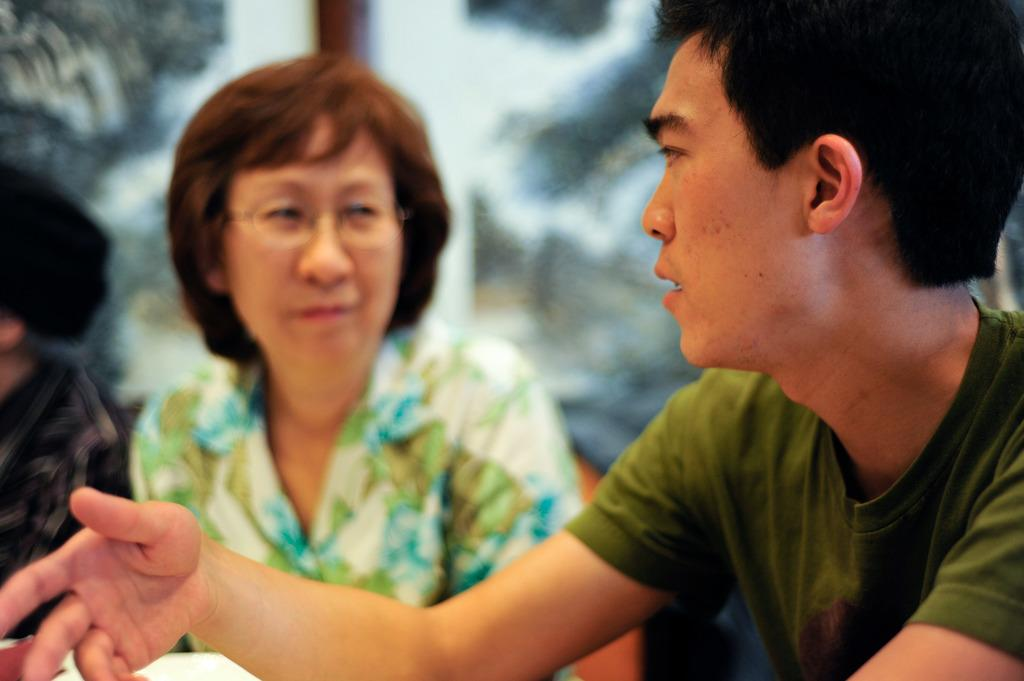What is the main subject of the image? The main subjects of the image are a man and a woman. What is the man doing in the image? The man is talking in the image. What can be observed about the woman in the image? The woman is wearing spectacles in the image. Can you describe the background of the image? The background of the image is blurry. Where is the toy located in the image? There is no toy present in the image. Can you describe the park setting in the image? There is no park setting in the image; it does not depict an outdoor environment. 